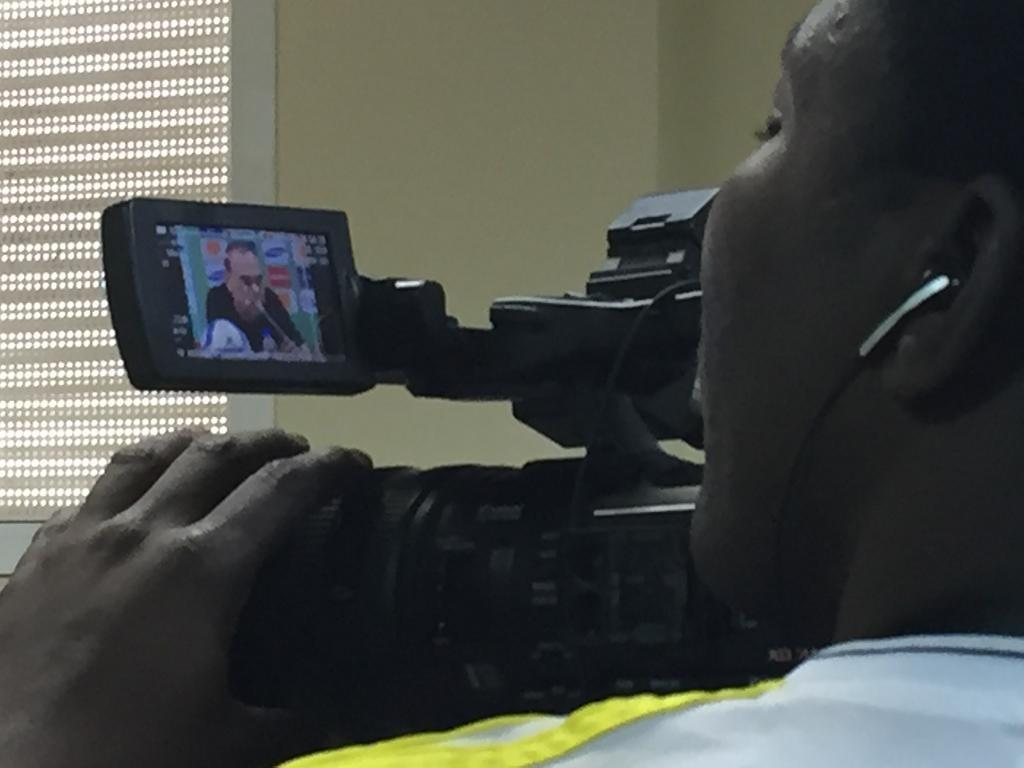What is the person in the image doing? The person is holding a camera and watching the video screen. What might the person be doing with the camera? The person might be taking photos or recording a video. How is the person interacting with the camera? The person is holding the camera and listening to the audio. What type of flowers can be seen growing in the mine in the image? There is no mine or flowers present in the image; it features a person holding a camera. 